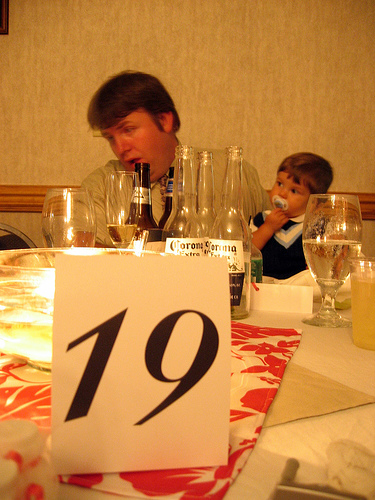<image>
Is there a boy behind the cup? Yes. From this viewpoint, the boy is positioned behind the cup, with the cup partially or fully occluding the boy. 